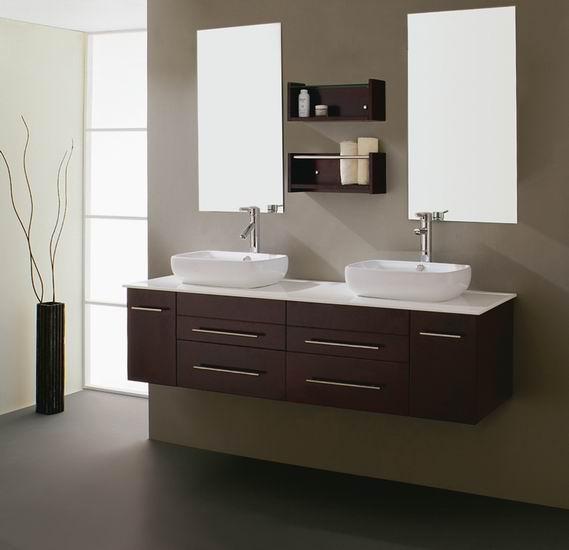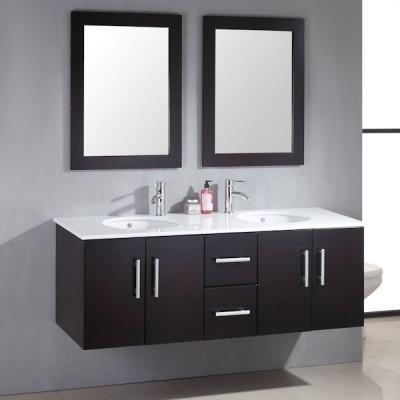The first image is the image on the left, the second image is the image on the right. For the images displayed, is the sentence "A bathroom features two black-framed rectangular mirrors over a double-sink vaniety with a black cabinet." factually correct? Answer yes or no. Yes. The first image is the image on the left, the second image is the image on the right. For the images shown, is this caption "One picture has mirrors with black borders" true? Answer yes or no. Yes. 